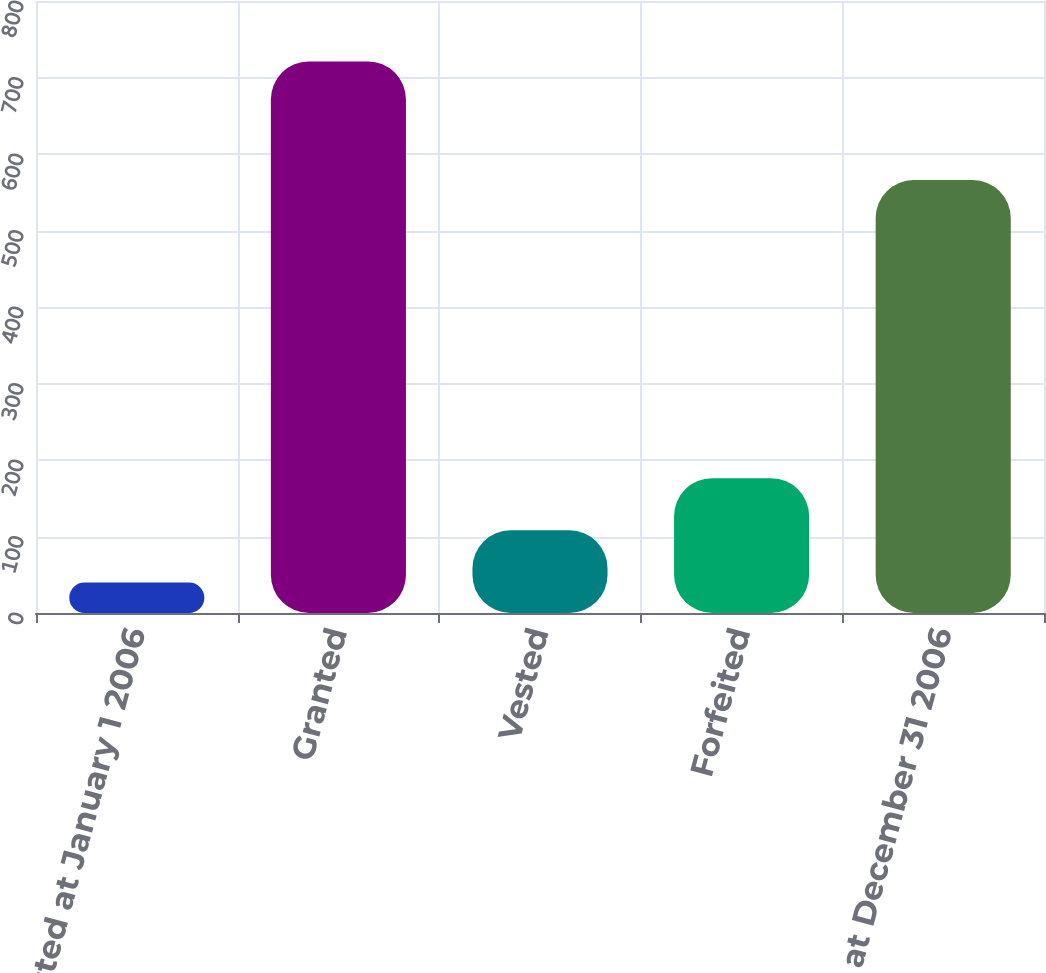Convert chart to OTSL. <chart><loc_0><loc_0><loc_500><loc_500><bar_chart><fcel>Nonvested at January 1 2006<fcel>Granted<fcel>Vested<fcel>Forfeited<fcel>Nonvested at December 31 2006<nl><fcel>40<fcel>721<fcel>108.1<fcel>176.2<fcel>566<nl></chart> 